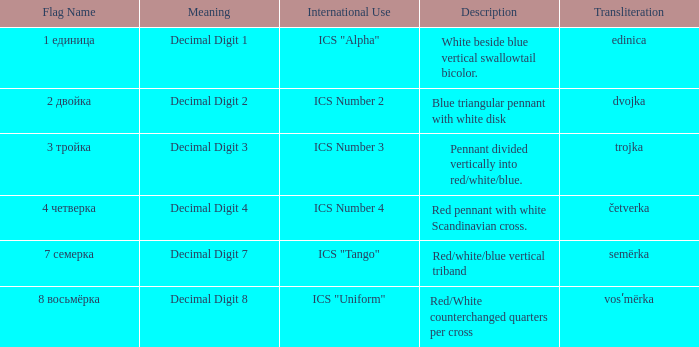What are the meanings of the flag whose name transliterates to semërka? Decimal Digit 7. 